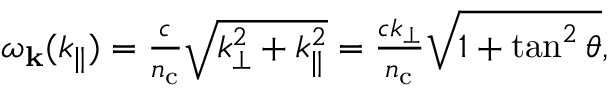Convert formula to latex. <formula><loc_0><loc_0><loc_500><loc_500>\begin{array} { r } { \omega _ { k } ( k _ { \| } ) = \frac { c } { n _ { c } } \sqrt { k _ { \perp } ^ { 2 } + k _ { \| } ^ { 2 } } = \frac { c k _ { \perp } } { n _ { c } } \sqrt { 1 + \tan ^ { 2 } \theta } , } \end{array}</formula> 